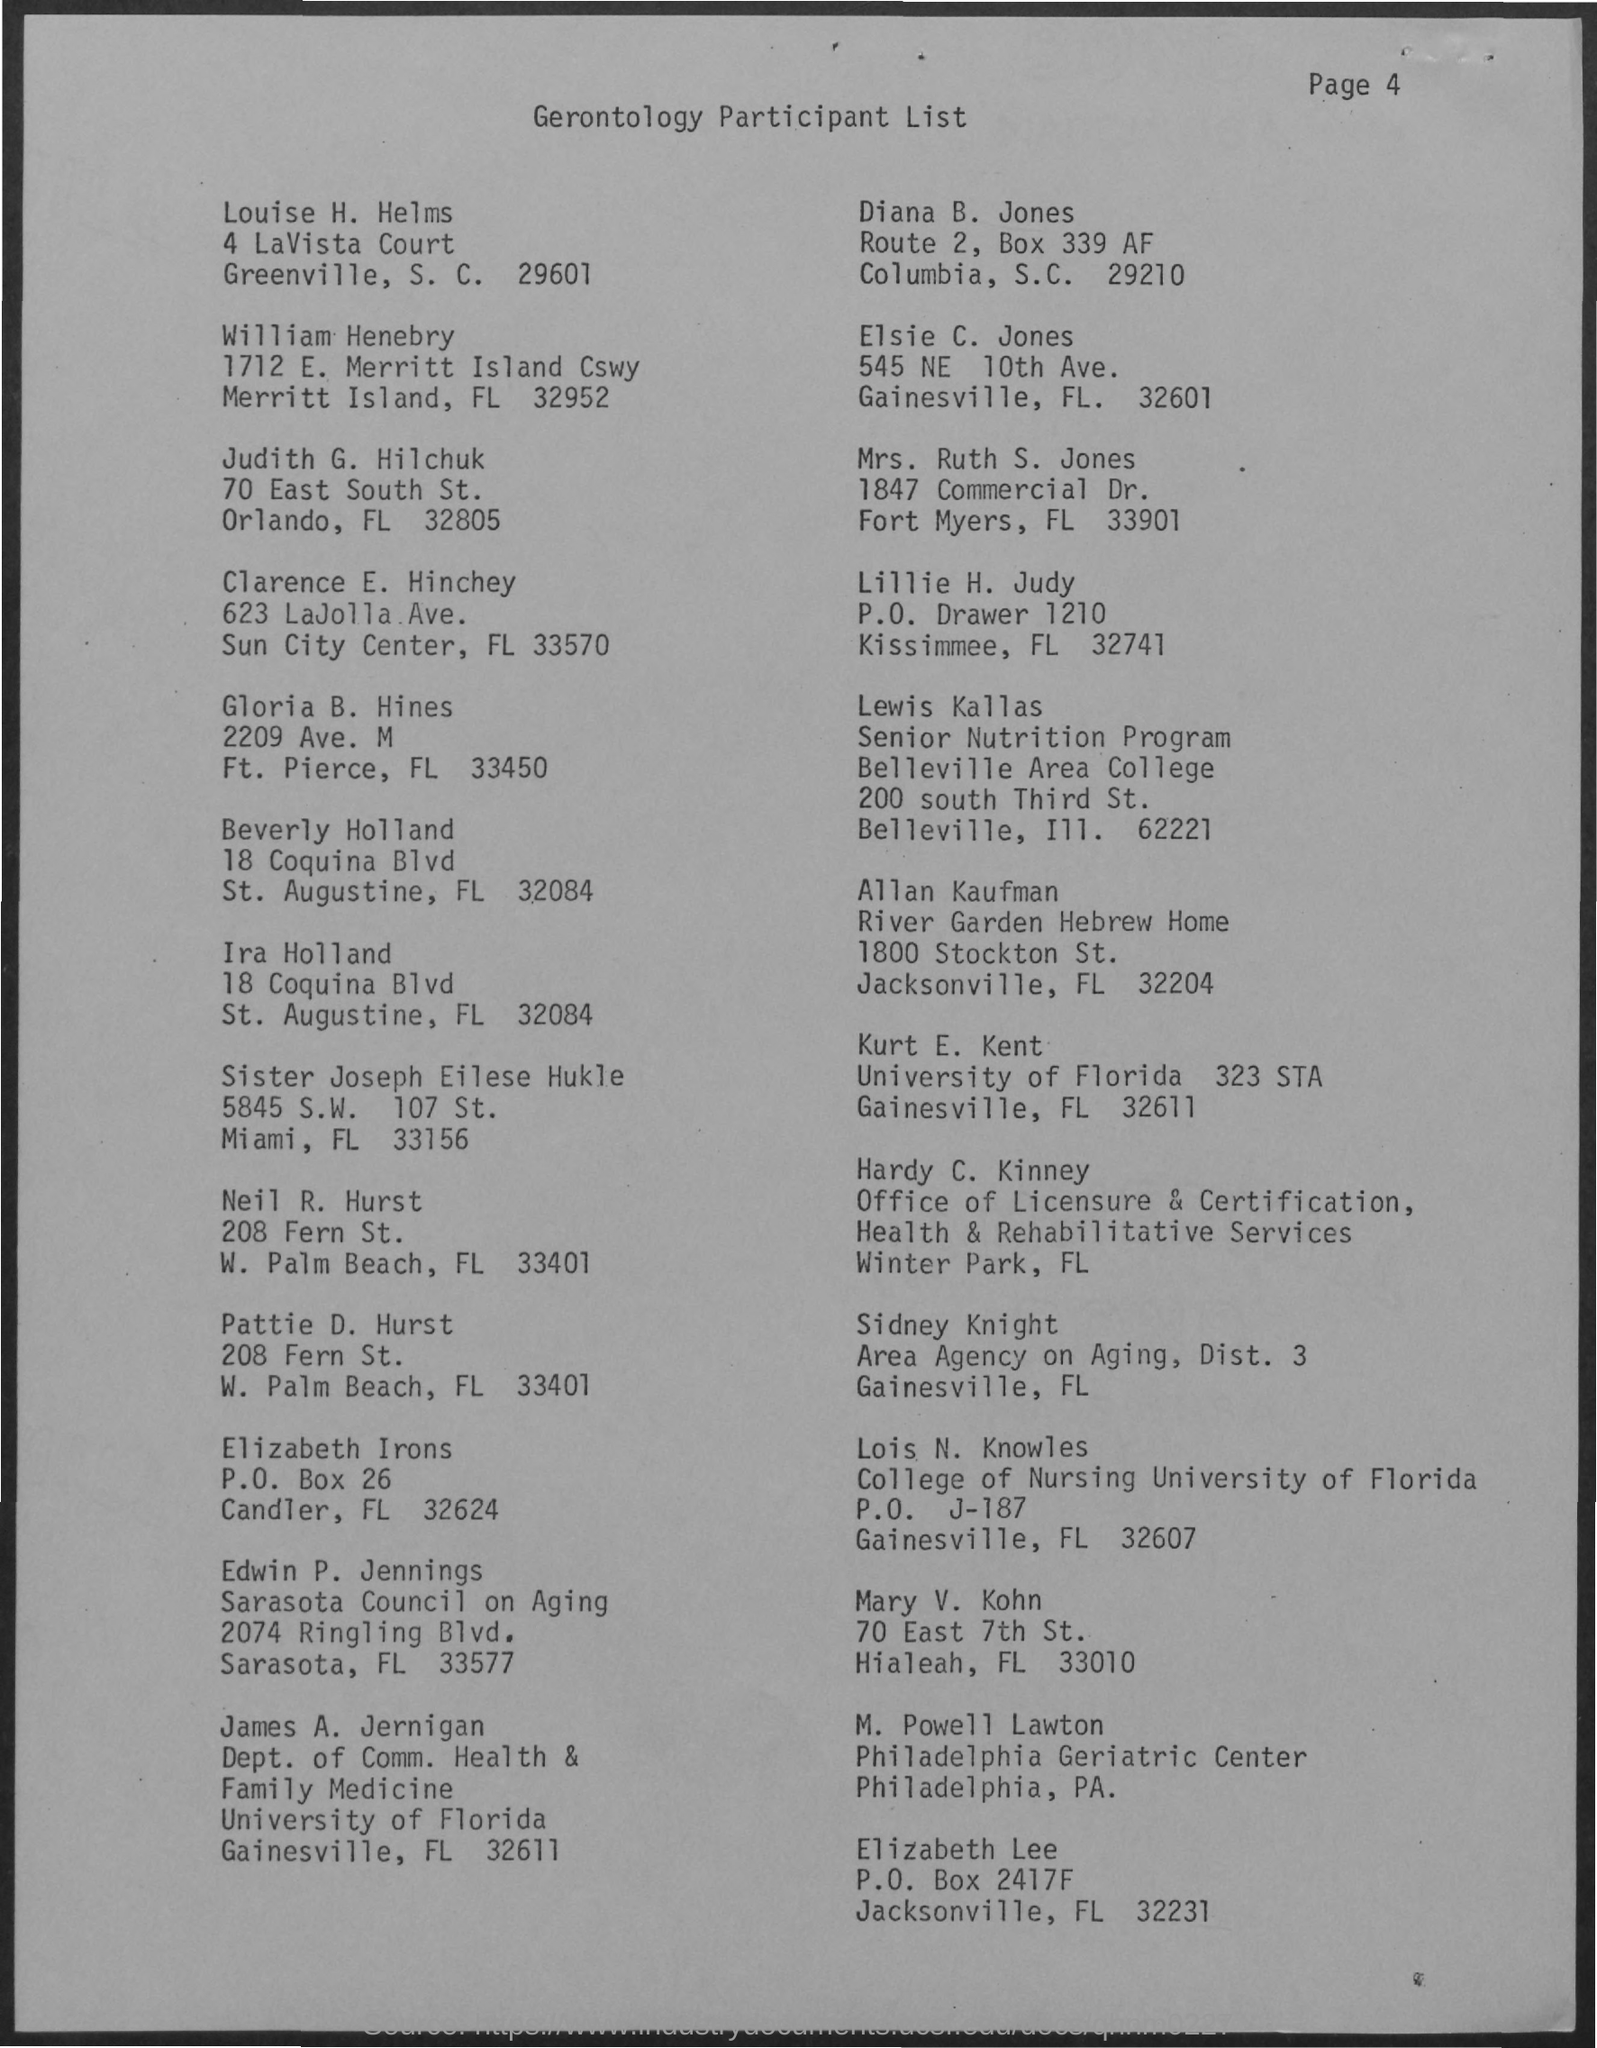Highlight a few significant elements in this photo. The document in question is titled "Gerontology Participant List. The page number is 4, as declared. 